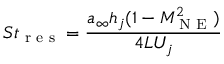Convert formula to latex. <formula><loc_0><loc_0><loc_500><loc_500>S t _ { r e s } = \frac { a _ { \infty } h _ { j } ( 1 - M _ { N E } ^ { 2 } ) } { 4 L U _ { j } }</formula> 